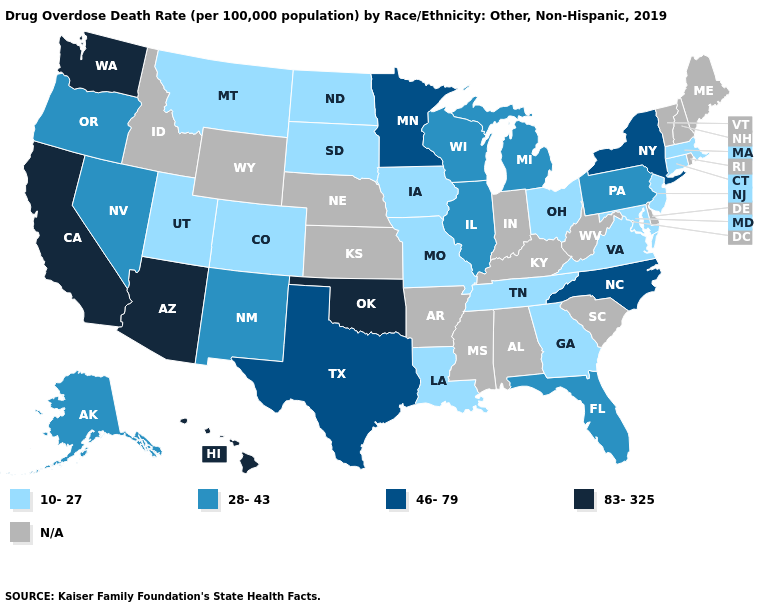What is the value of Vermont?
Be succinct. N/A. Does Michigan have the lowest value in the USA?
Answer briefly. No. What is the value of New Mexico?
Write a very short answer. 28-43. Name the states that have a value in the range 28-43?
Keep it brief. Alaska, Florida, Illinois, Michigan, Nevada, New Mexico, Oregon, Pennsylvania, Wisconsin. Name the states that have a value in the range 83-325?
Short answer required. Arizona, California, Hawaii, Oklahoma, Washington. Among the states that border California , does Nevada have the highest value?
Write a very short answer. No. Name the states that have a value in the range 28-43?
Answer briefly. Alaska, Florida, Illinois, Michigan, Nevada, New Mexico, Oregon, Pennsylvania, Wisconsin. What is the value of Texas?
Be succinct. 46-79. What is the value of Oregon?
Short answer required. 28-43. Does Hawaii have the highest value in the West?
Answer briefly. Yes. Does Montana have the highest value in the USA?
Quick response, please. No. Does the first symbol in the legend represent the smallest category?
Answer briefly. Yes. Name the states that have a value in the range N/A?
Short answer required. Alabama, Arkansas, Delaware, Idaho, Indiana, Kansas, Kentucky, Maine, Mississippi, Nebraska, New Hampshire, Rhode Island, South Carolina, Vermont, West Virginia, Wyoming. 